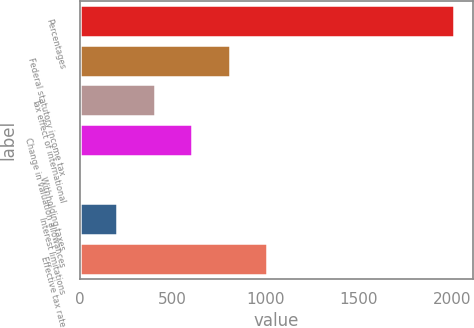Convert chart. <chart><loc_0><loc_0><loc_500><loc_500><bar_chart><fcel>Percentages<fcel>Federal statutory income tax<fcel>Tax effect of international<fcel>Change in valuation allowances<fcel>Withholding taxes<fcel>Interest limitations<fcel>Effective tax rate<nl><fcel>2015<fcel>806.36<fcel>403.48<fcel>604.92<fcel>0.6<fcel>202.04<fcel>1007.8<nl></chart> 